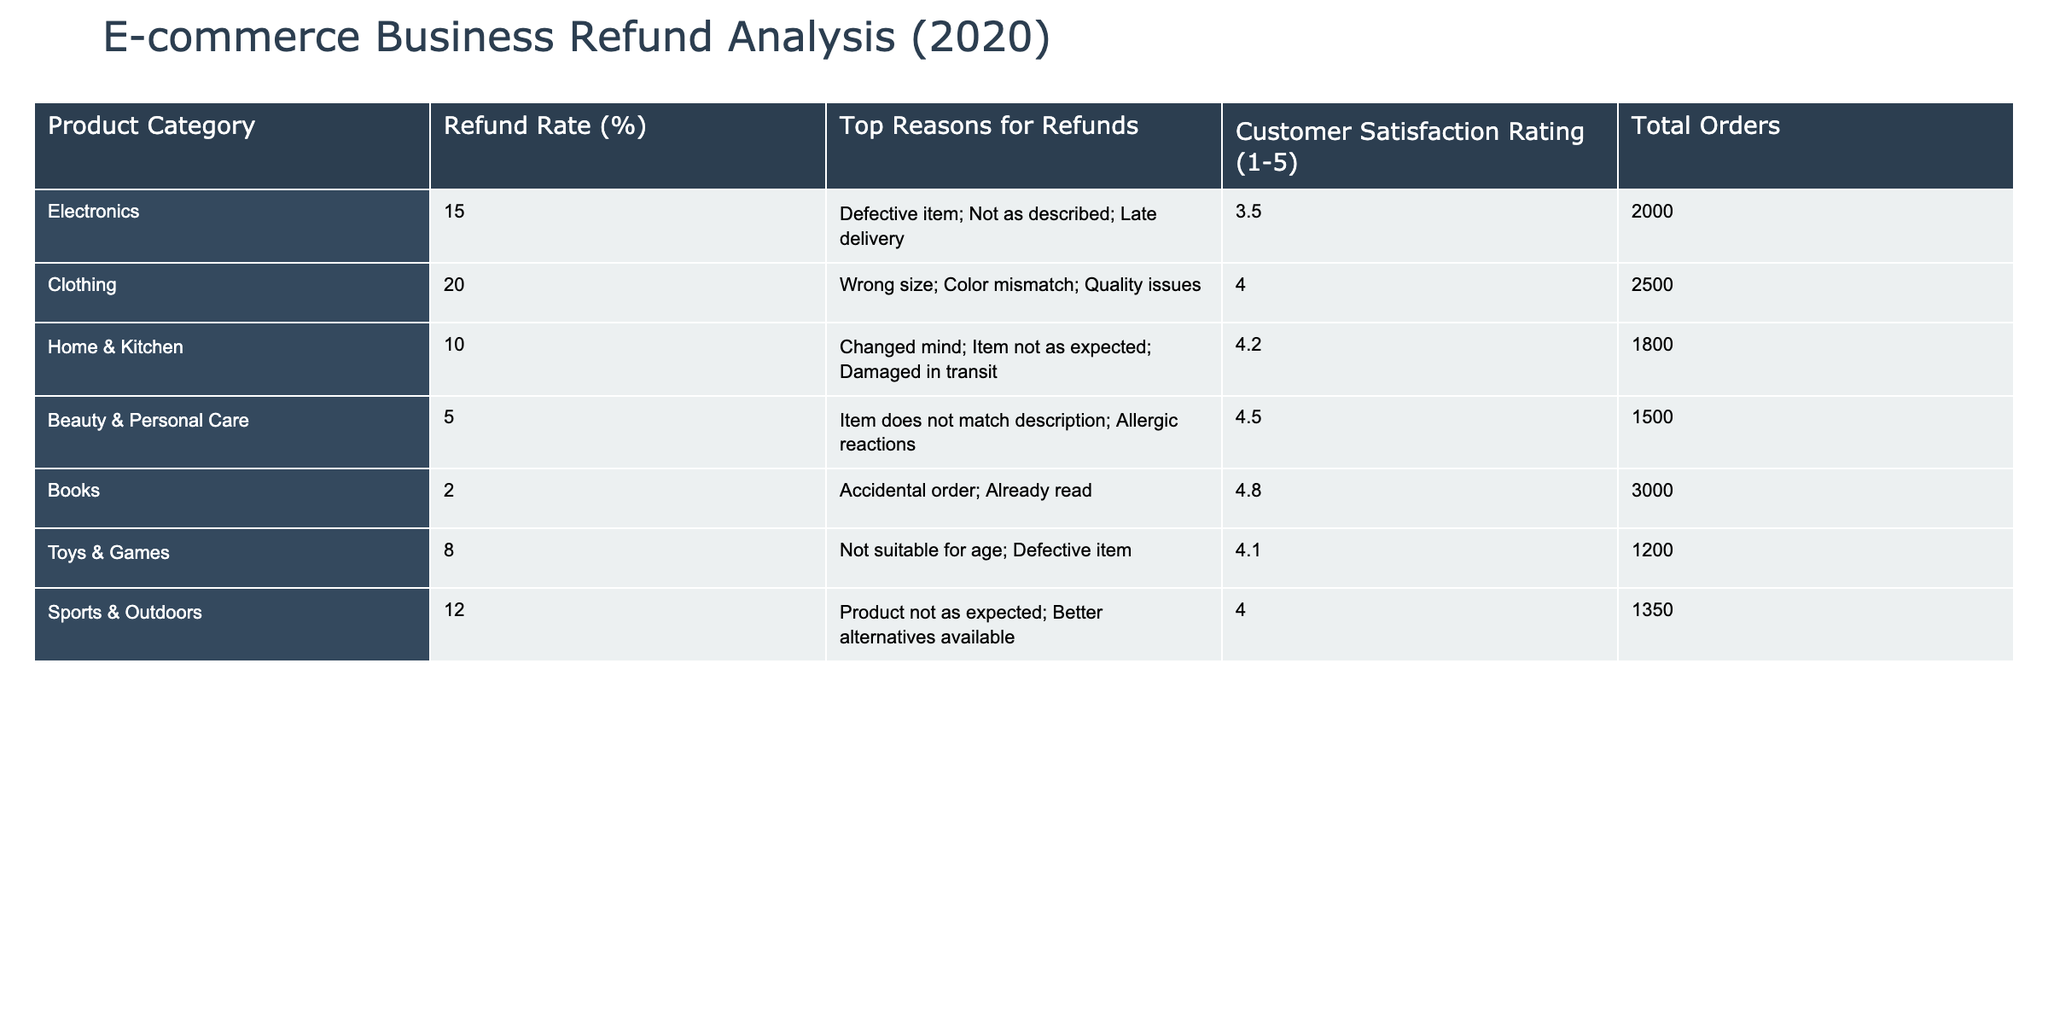What is the refund rate for Electronics? The table shows the refund rate for the Electronics category as 15%. This value is directly referenced from the corresponding row for Electronics.
Answer: 15% What are the top two reasons for refund in the Clothing category? In the Clothing category, the top reasons for refund are listed as "Wrong size" and "Color mismatch." These reasons are directly mentioned in the corresponding row for Clothing.
Answer: Wrong size; Color mismatch Is the refund rate for Beauty & Personal Care higher than for Home & Kitchen? The refund rate for Beauty & Personal Care is 5%, while for Home & Kitchen it is 10%. Since 5% is less than 10%, the statement is false.
Answer: No What is the customer satisfaction rating for the Toys & Games category? The table lists the customer satisfaction rating for Toys & Games as 4.1. This is stated in the corresponding row for that category.
Answer: 4.1 Which product category has the highest refund rate? By comparing all refund rates in the table, Clothing has the highest refund rate at 20%. This is found by observing the percentage values in the Refund Rate column and identifying the maximum.
Answer: Clothing What is the total number of orders placed for products in the Home & Kitchen category? The table indicates that there were 1800 total orders placed in the Home & Kitchen category. This information is located in the respective row for that category.
Answer: 1800 What is the average refund rate across all product categories? To find the average refund rate, we sum the refund rates: 15 + 20 + 10 + 5 + 2 + 8 + 12 = 72. There are 7 categories, so the average is 72/7 ≈ 10.29%.
Answer: Approximately 10.29% Are there more refunds for Toys & Games because of defective items than for Sports & Outdoors for better alternatives? In Toys & Games, the reason for refund includes "Defective item," while in Sports & Outdoors, it includes "Better alternatives available." We need to check if the refund reasons imply a higher incidence. The analysis is complex as it requires qualitative assessment, but generally, "Defective item" often leads to more refunds than switching for alternatives. Thus, determining an explicit count from the data is not possible. However, reflecting on definitions usually suggests that defective items would likely lead to a higher refund scenario compared to choosing alternatives.
Answer: Yes Which product category has both the highest refund rate and the lowest customer satisfaction rating? The category with the highest refund rate is Clothing at 20%, but with the lowest customer satisfaction rating being 3.5 in the Electronics category. Since no single category has both the highest refund rate and the lowest satisfaction, the answer is that no category fits both criteria simultaneously.
Answer: No category fits both criteria 